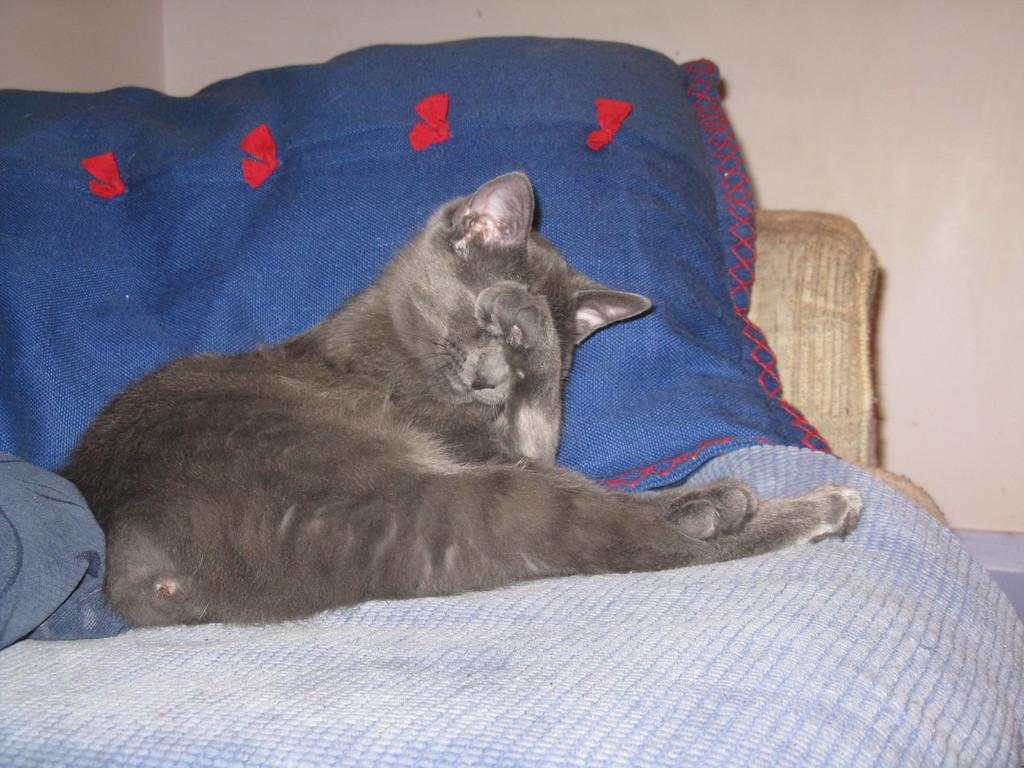What type of animal is in the image? There is a cat in the image. What is the cat sitting on? The cat is on a cloth. What other object can be seen in the image? There is a pillow in the image. What is visible in the background of the image? There is a wall in the background of the image. How many potatoes are on the cat's head in the image? There are no potatoes present in the image, and therefore none are on the cat's head. 